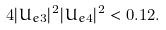Convert formula to latex. <formula><loc_0><loc_0><loc_500><loc_500>4 | U _ { e 3 } | ^ { 2 } | U _ { e 4 } | ^ { 2 } < 0 . 1 2 .</formula> 